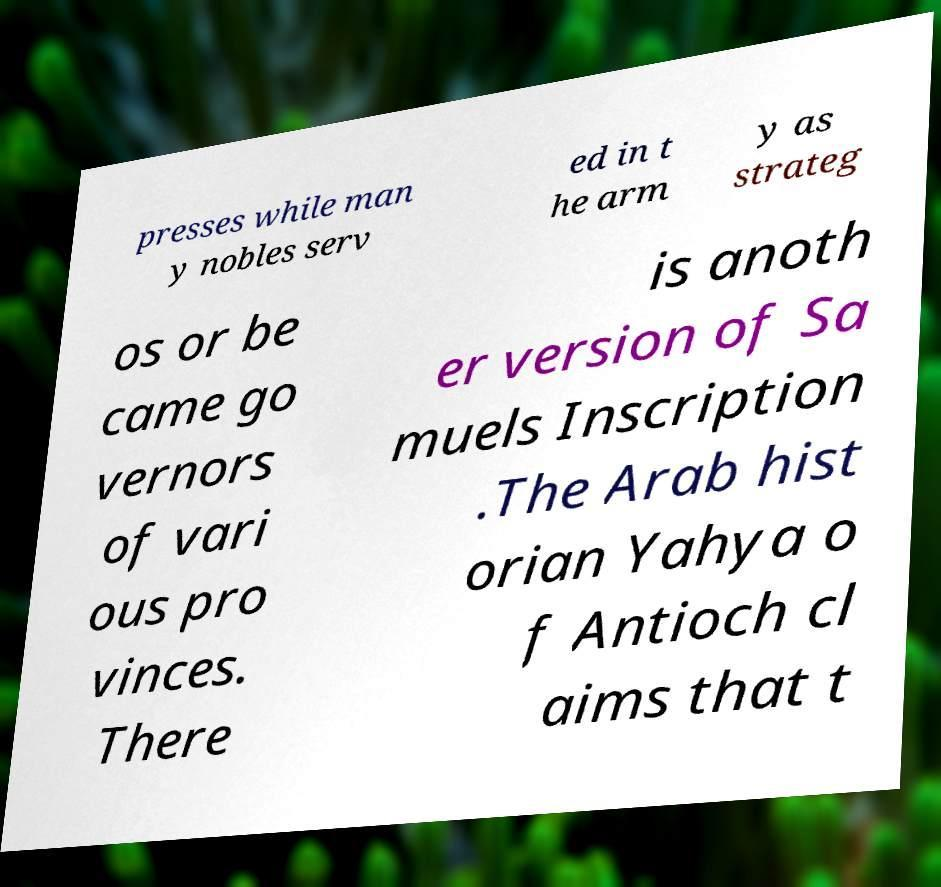Could you assist in decoding the text presented in this image and type it out clearly? presses while man y nobles serv ed in t he arm y as strateg os or be came go vernors of vari ous pro vinces. There is anoth er version of Sa muels Inscription .The Arab hist orian Yahya o f Antioch cl aims that t 